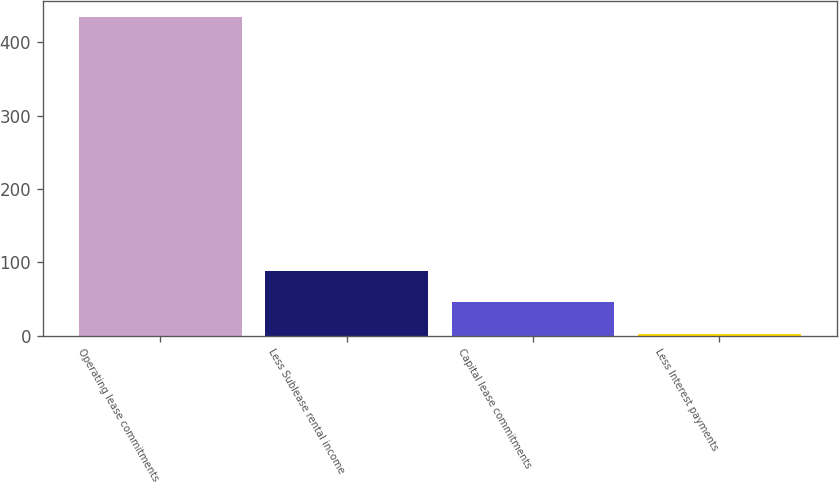Convert chart to OTSL. <chart><loc_0><loc_0><loc_500><loc_500><bar_chart><fcel>Operating lease commitments<fcel>Less Sublease rental income<fcel>Capital lease commitments<fcel>Less Interest payments<nl><fcel>435<fcel>88.6<fcel>45.3<fcel>2<nl></chart> 